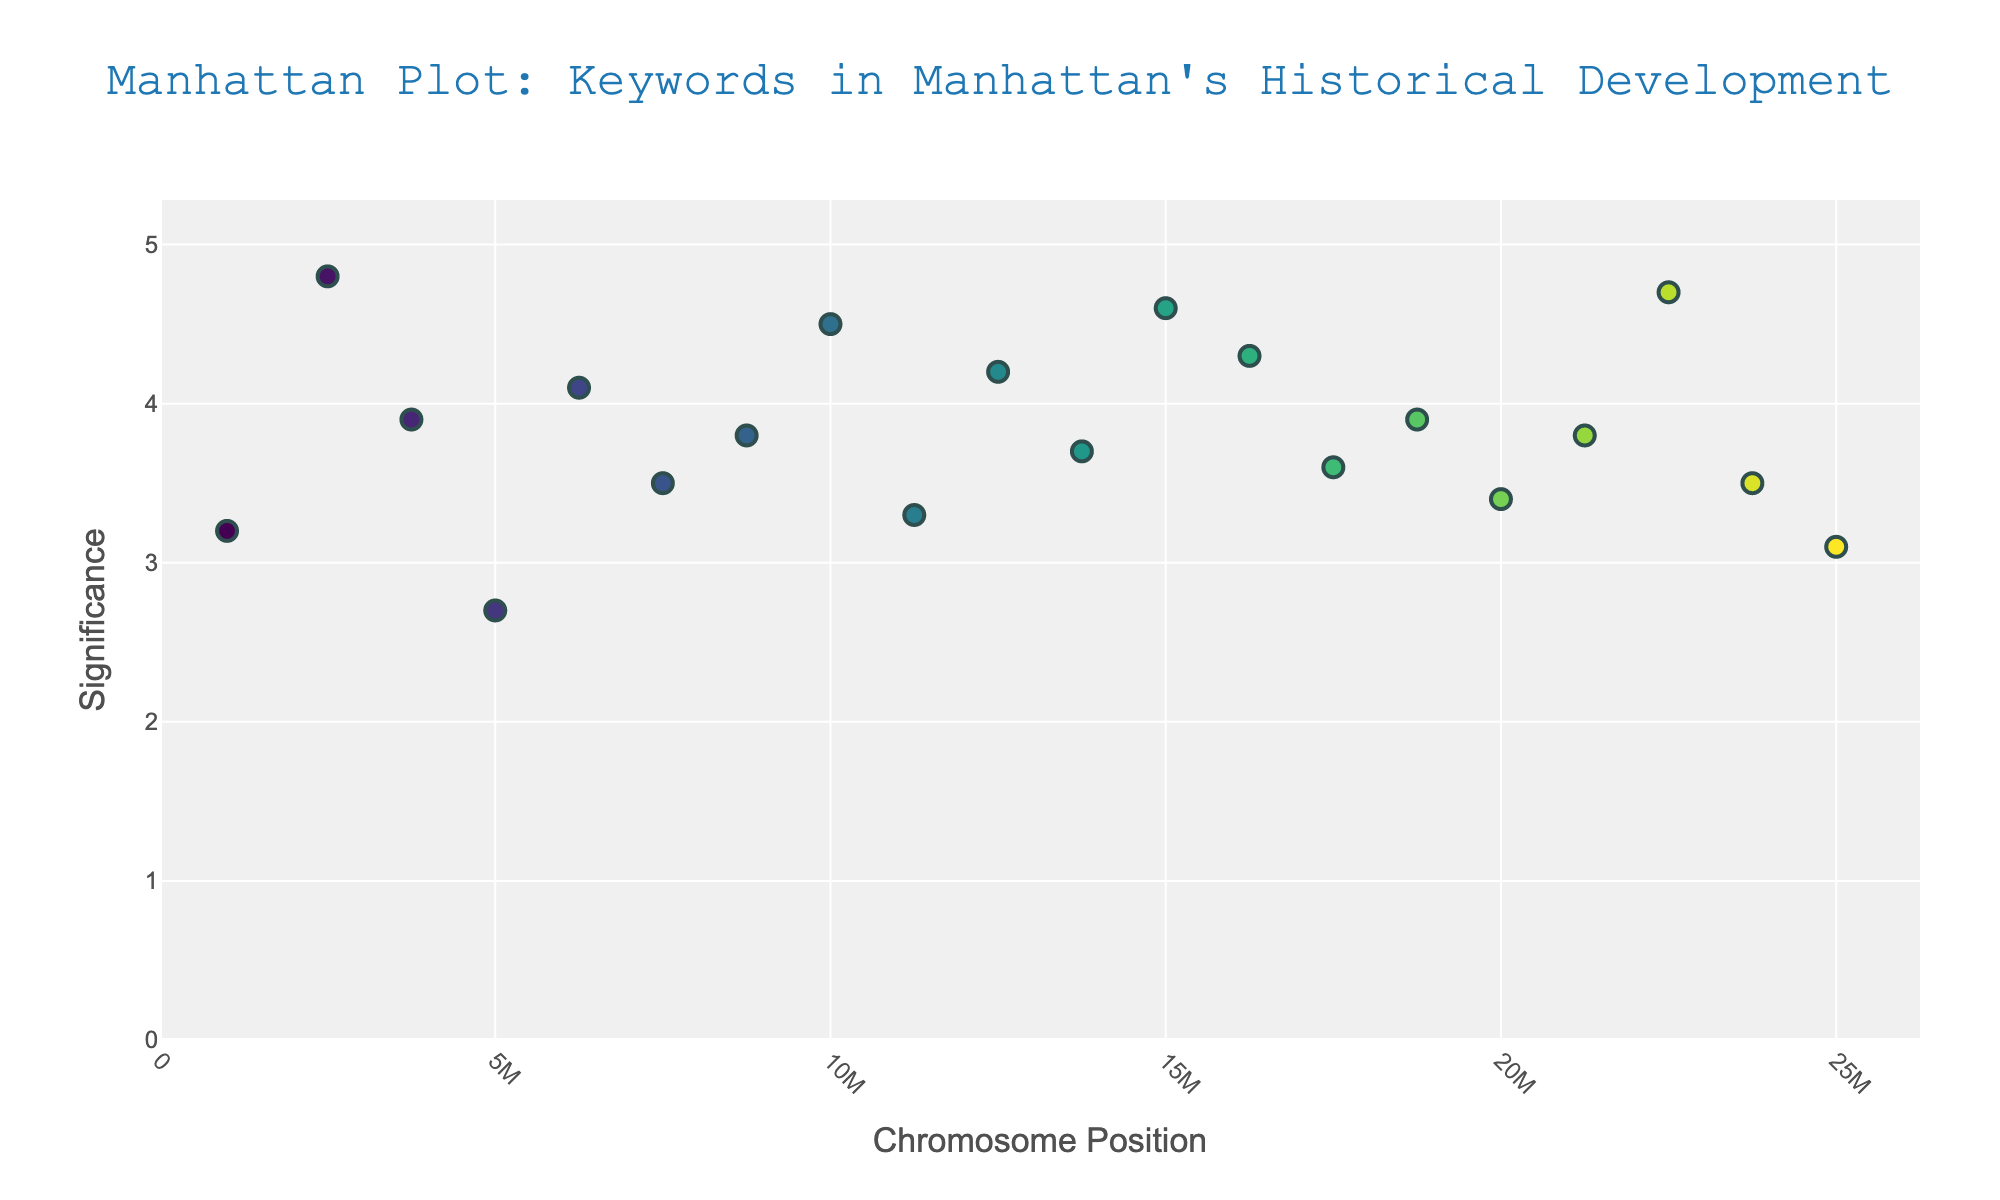What's the title of the figure? The title is indicated at the top of the plot. The title is "Manhattan Plot: Keywords in Manhattan's Historical Development".
Answer: Manhattan Plot: Keywords in Manhattan's Historical Development How many keywords have a significance greater than 4.0? By looking at the y-axis and identifying the points above the 4.0 mark, we count the number of data points. The keywords with significance > 4.0 are "New Amsterdam", "Revolutionary War", "Immigration", "Central Park", "Statue of Liberty", "Ellis Island", and "World Trade Center". This totals to 7 points.
Answer: 7 Which keyword is found at the highest chromosome position? Chromosome position is indicated on the x-axis. The keyword positioned furthest to the right is at position 25,000,000, which corresponds to "Gentrification".
Answer: Gentrification What is the average significance of keywords on chromosome 18? To find the average significance for chromosome 18, locate the significance values for this chromosome ("World Trade Center"). The significance value is 4.7. The average is 4.7, as there's only one data point.
Answer: 4.7 Which keyword has the lowest significance value? By examining the y-axis for the point closest to the bottom, it is the point "British" at significance 2.7.
Answer: British Between the keywords "Wall Street" and "Statue of Liberty", which has a higher significance? Compare the significance values on the y-axis for "Wall Street" (3.9) and "Statue of Liberty" (4.6). "Statue of Liberty" has a higher significance.
Answer: Statue of Liberty What is the significance range of the keywords from chromosome 1 to chromosome 5? Identify the significance values for keywords on chromosomes 1 to 5 which are: Dutch (3.2), New Amsterdam (4.8), Wall Street (3.9), British (2.7), Revolutionary War (4.1). Range is max value - min value = 4.8 - 2.7 = 2.1.
Answer: 2.1 How many chromosomes have exactly one keyword with significance greater than 4? Identify the chromosomes with one data point having significance > 4. The chromosomes are 2 (New Amsterdam), 5 (Revolutionary War), 8 (Immigration), 10 (Central Park), 12 (Statue of Liberty), 13 (Ellis Island), 18 (World Trade Center). This totals to 7 chromosomes.
Answer: 7 Which chromosome has the most keywords visualized? By looking at the x-axis annotations, each chromosome has only one data point. Therefore, each chromosome has the same number of keywords represented.
Answer: Equal across all chromosomes 